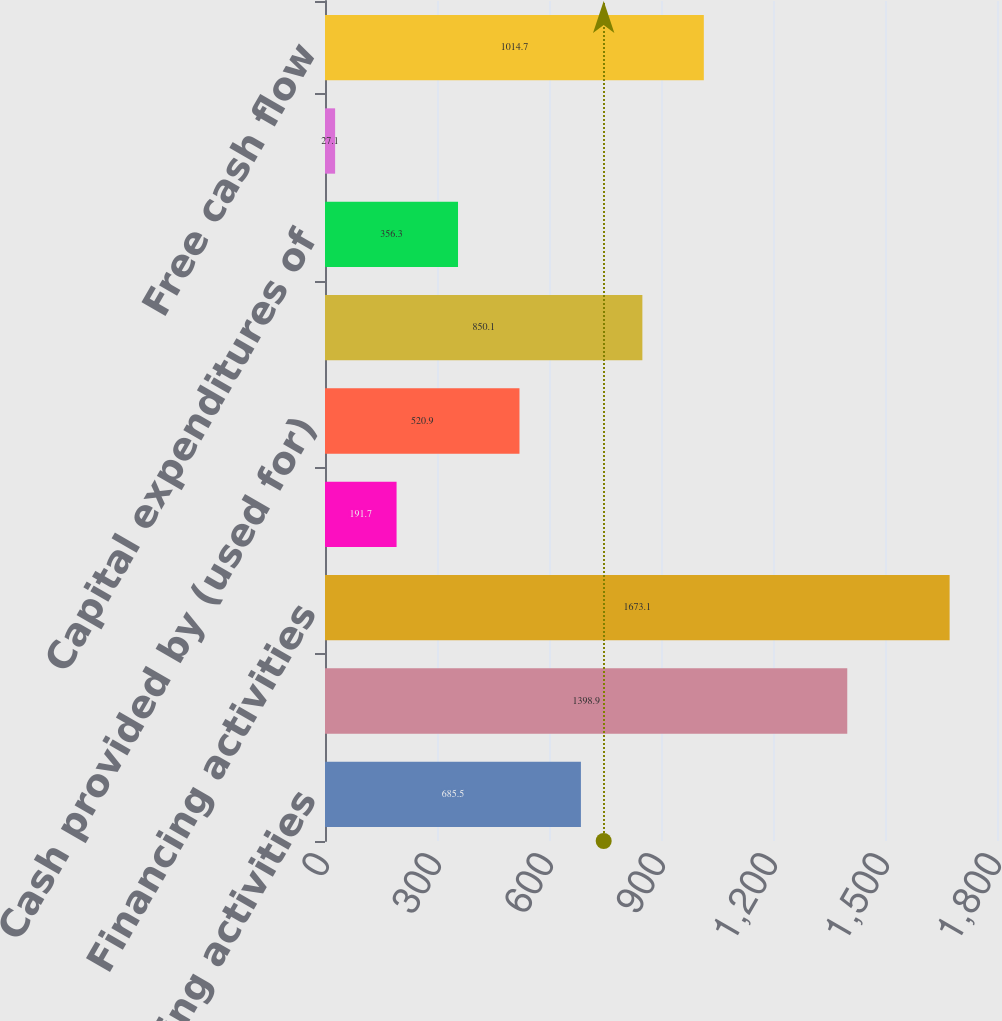<chart> <loc_0><loc_0><loc_500><loc_500><bar_chart><fcel>Operating activities<fcel>Investing activities<fcel>Financing activities<fcel>Effect of exchange rate<fcel>Cash provided by (used for)<fcel>Cash provided by continuing<fcel>Capital expenditures of<fcel>Excess income tax benefit from<fcel>Free cash flow<nl><fcel>685.5<fcel>1398.9<fcel>1673.1<fcel>191.7<fcel>520.9<fcel>850.1<fcel>356.3<fcel>27.1<fcel>1014.7<nl></chart> 